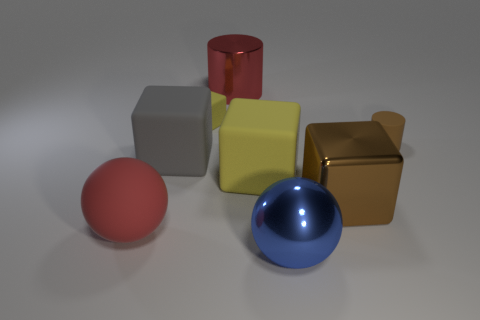Is there any other thing that has the same color as the big shiny cylinder?
Offer a very short reply. Yes. What color is the big matte sphere?
Provide a succinct answer. Red. Are there any other things that have the same material as the tiny cylinder?
Keep it short and to the point. Yes. How many other things are the same shape as the tiny brown matte thing?
Offer a very short reply. 1. How many big metal objects are behind the large object right of the sphere that is on the right side of the metallic cylinder?
Your response must be concise. 1. What number of other large metallic things have the same shape as the large brown object?
Provide a short and direct response. 0. There is a small thing that is left of the big red shiny object; is its color the same as the shiny block?
Give a very brief answer. No. There is a red thing in front of the matte cube that is on the right side of the small matte thing that is to the left of the tiny brown rubber object; what shape is it?
Your answer should be very brief. Sphere. Do the brown metallic thing and the rubber thing that is to the right of the blue object have the same size?
Your response must be concise. No. Are there any cylinders that have the same size as the metal ball?
Ensure brevity in your answer.  Yes. 